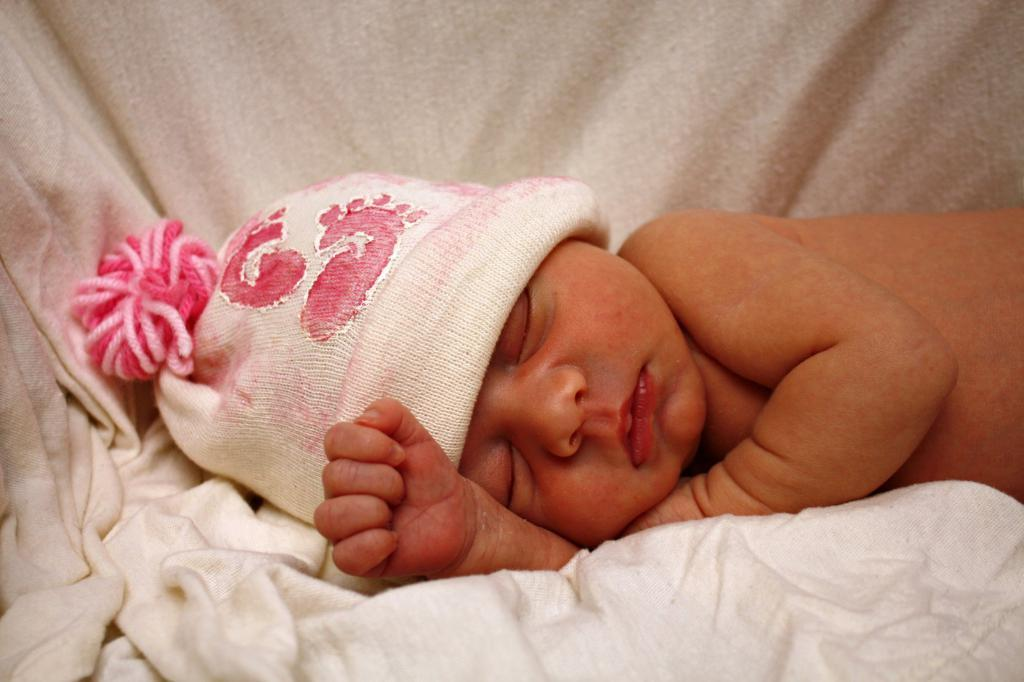What is the main subject of the image? There is a small baby in the image. What is the baby doing in the image? The baby is sleeping. What is covering the baby in the image? There is a blanket in the image. What is the baby wearing on their head? The baby is wearing a hat. How many ants can be seen crawling on the baby's hat in the image? There are no ants present in the image, so it is not possible to determine how many ants might be on the baby's hat. 